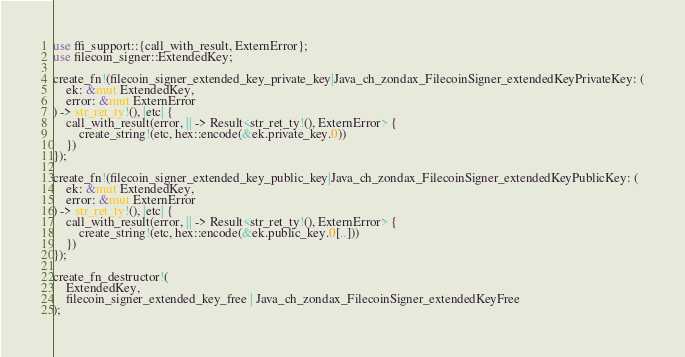Convert code to text. <code><loc_0><loc_0><loc_500><loc_500><_Rust_>use ffi_support::{call_with_result, ExternError};
use filecoin_signer::ExtendedKey;

create_fn!(filecoin_signer_extended_key_private_key|Java_ch_zondax_FilecoinSigner_extendedKeyPrivateKey: (
    ek: &mut ExtendedKey,
    error: &mut ExternError
) -> str_ret_ty!(), |etc| {
    call_with_result(error, || -> Result<str_ret_ty!(), ExternError> {
        create_string!(etc, hex::encode(&ek.private_key.0))
    })
});

create_fn!(filecoin_signer_extended_key_public_key|Java_ch_zondax_FilecoinSigner_extendedKeyPublicKey: (
    ek: &mut ExtendedKey,
    error: &mut ExternError
) -> str_ret_ty!(), |etc| {
    call_with_result(error, || -> Result<str_ret_ty!(), ExternError> {
        create_string!(etc, hex::encode(&ek.public_key.0[..]))
    })
});

create_fn_destructor!(
    ExtendedKey,
    filecoin_signer_extended_key_free | Java_ch_zondax_FilecoinSigner_extendedKeyFree
);
</code> 